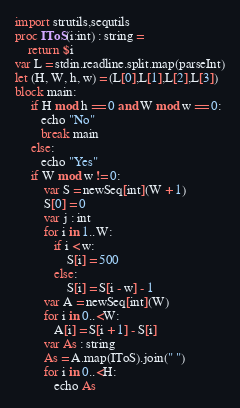<code> <loc_0><loc_0><loc_500><loc_500><_Nim_>import strutils,sequtils
proc IToS(i:int) : string =
    return $i
var L = stdin.readline.split.map(parseInt)
let (H, W, h, w) = (L[0],L[1],L[2],L[3])
block main:
     if H mod h == 0 and W mod w == 0:
        echo "No"
        break main
     else:
        echo "Yes"
     if W mod w != 0:
         var S = newSeq[int](W + 1)
         S[0] = 0
         var j : int
         for i in 1..W:
            if i < w:
                S[i] = 500
            else:
                S[i] = S[i - w] - 1
         var A = newSeq[int](W)
         for i in 0..<W:
            A[i] = S[i + 1] - S[i]
         var As : string
         As = A.map(IToS).join(" ")
         for i in 0..<H:
            echo As</code> 